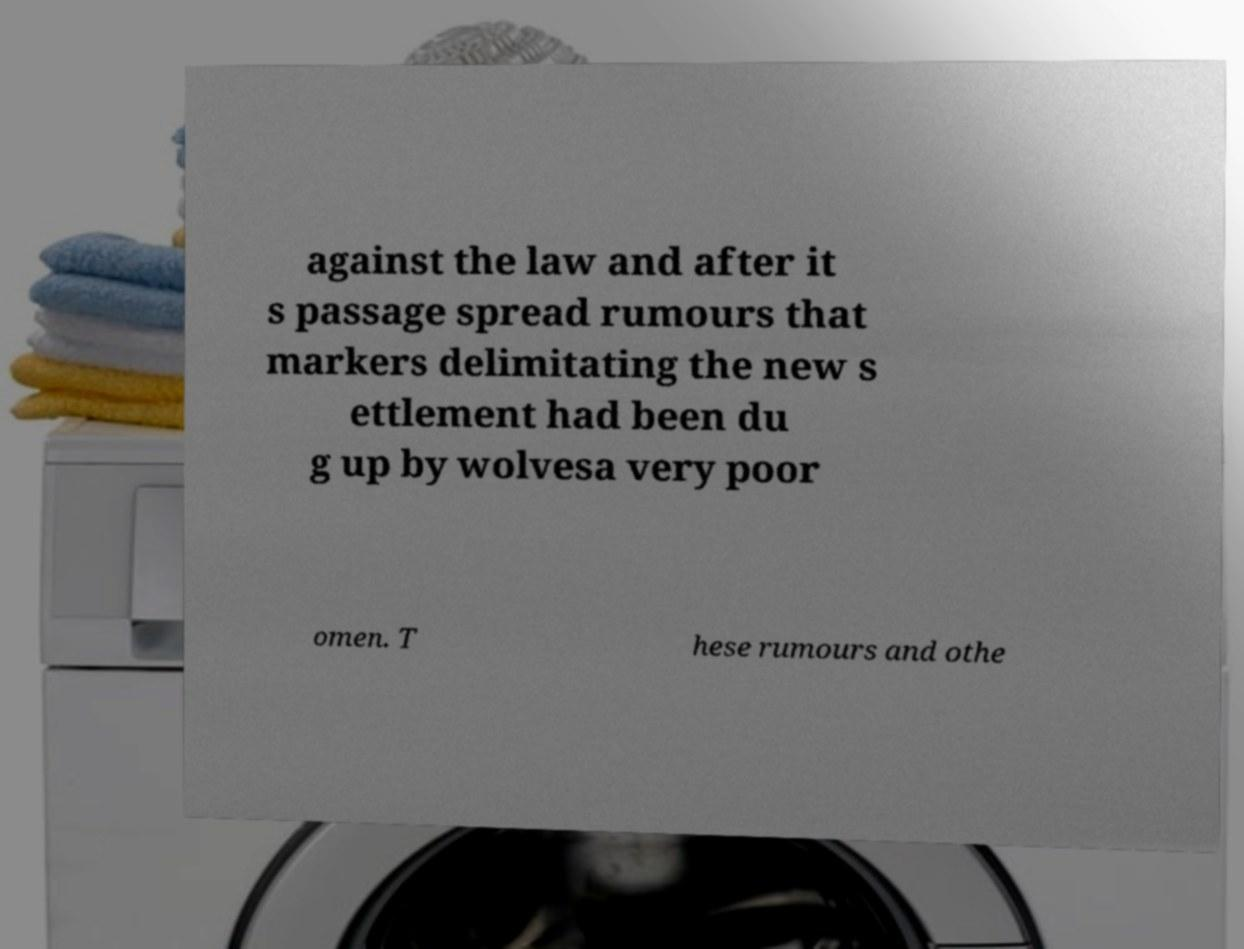What messages or text are displayed in this image? I need them in a readable, typed format. against the law and after it s passage spread rumours that markers delimitating the new s ettlement had been du g up by wolvesa very poor omen. T hese rumours and othe 